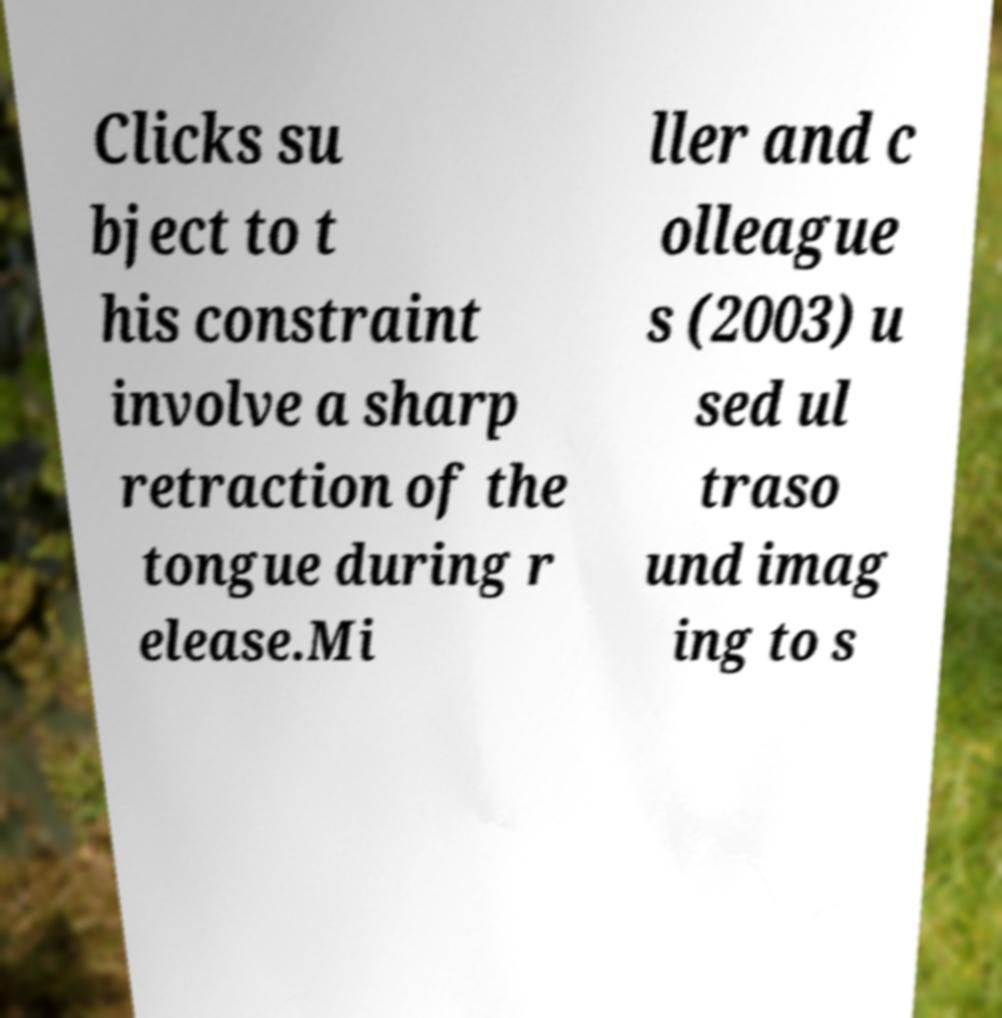Could you assist in decoding the text presented in this image and type it out clearly? Clicks su bject to t his constraint involve a sharp retraction of the tongue during r elease.Mi ller and c olleague s (2003) u sed ul traso und imag ing to s 